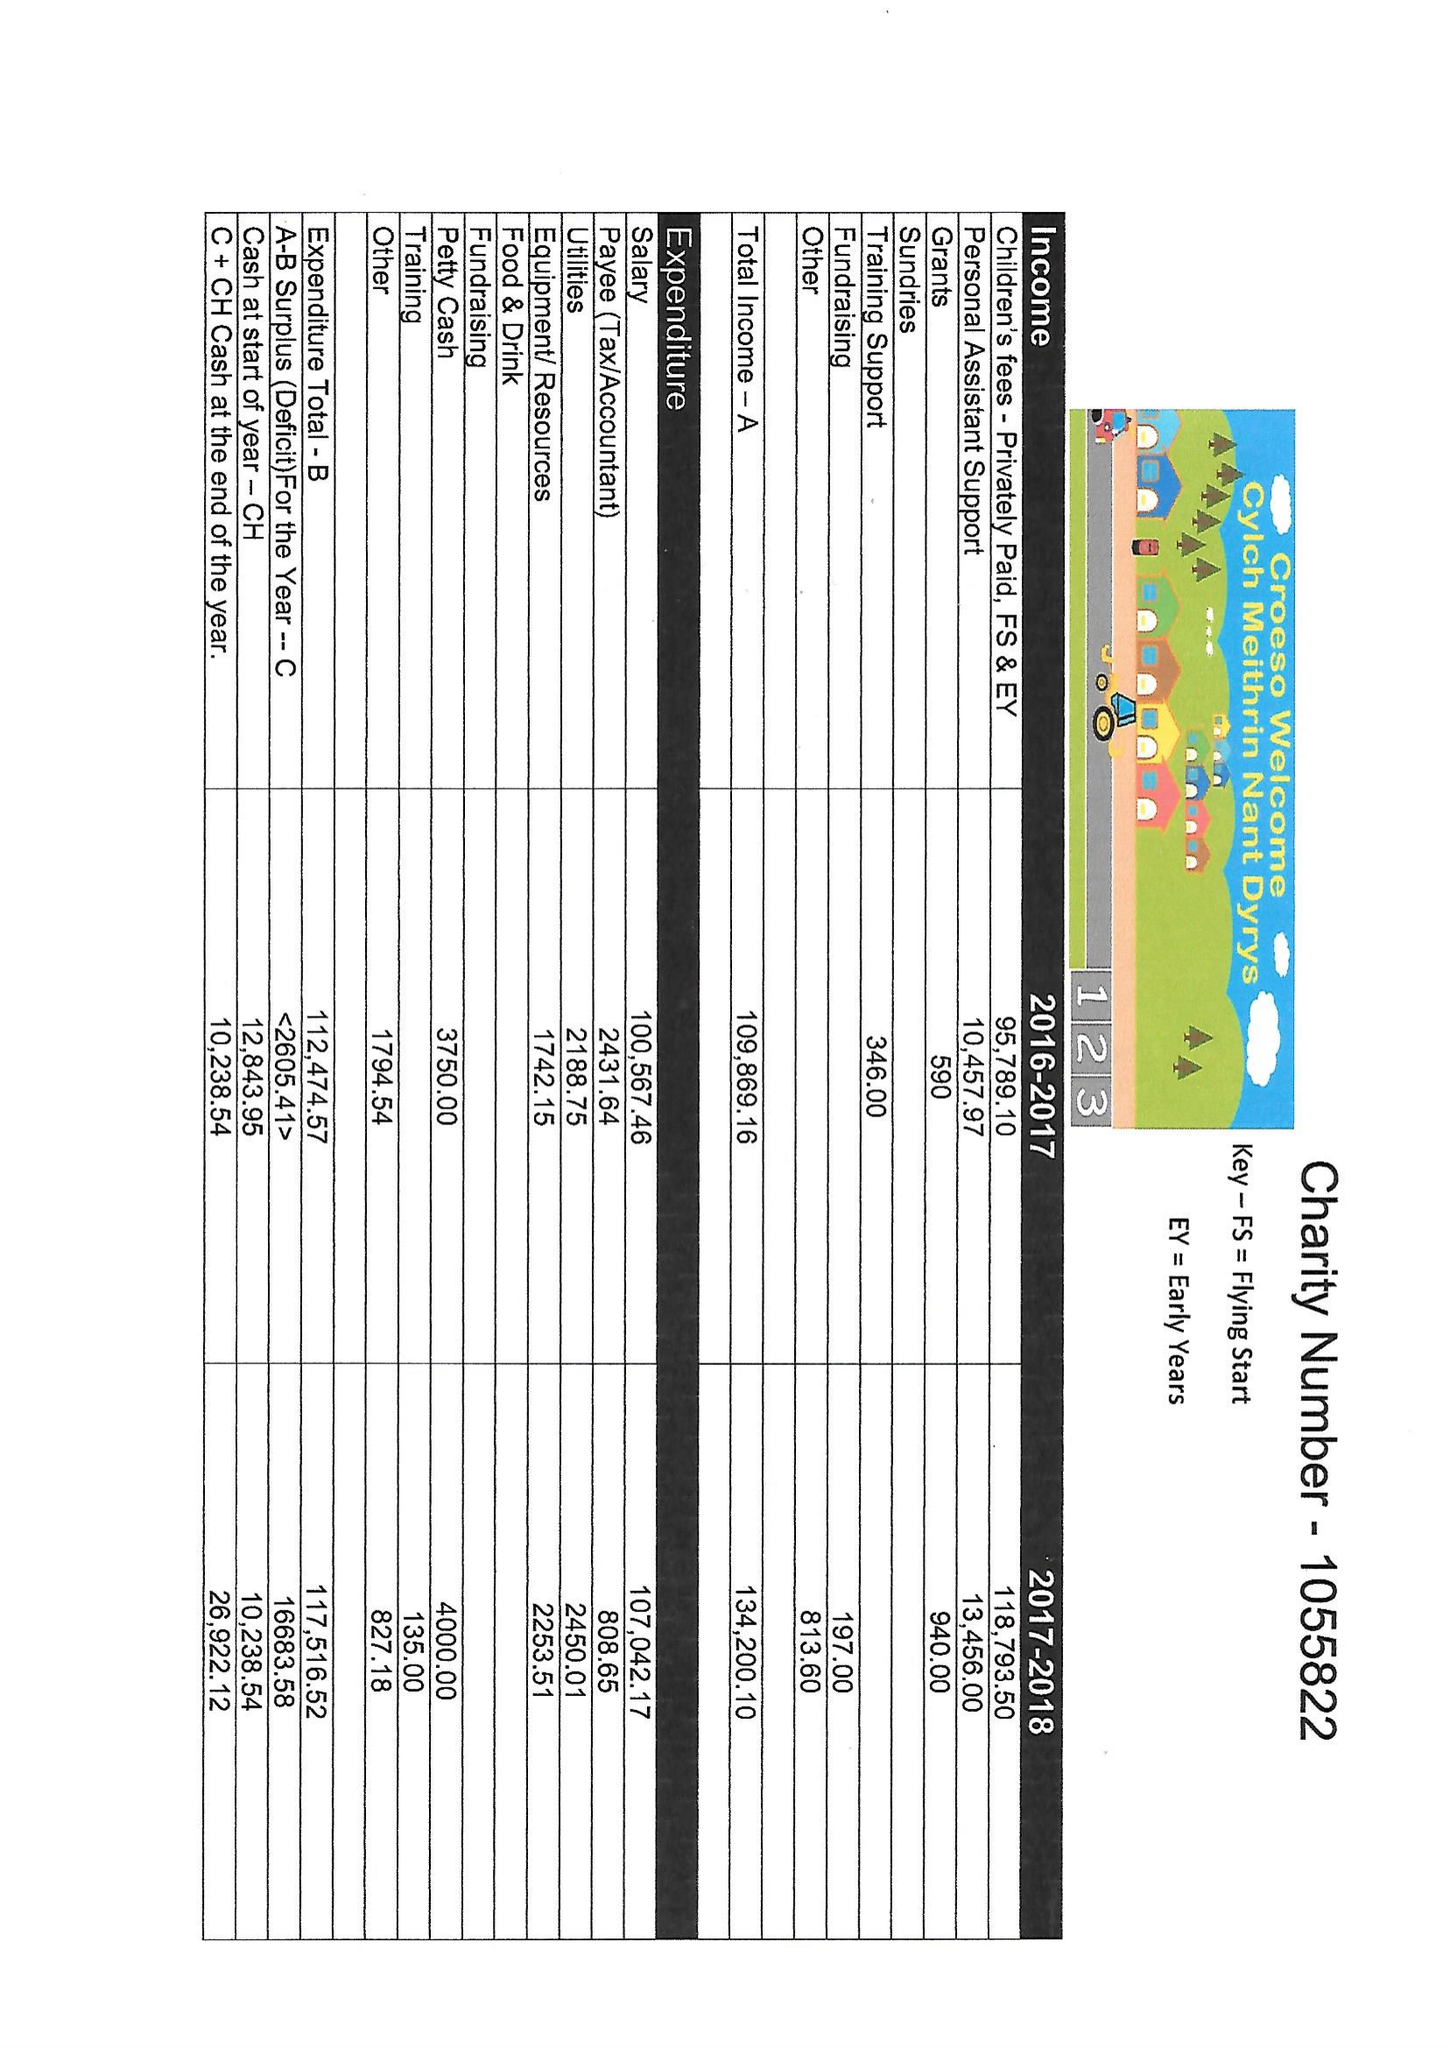What is the value for the address__street_line?
Answer the question using a single word or phrase. CLINIC ROAD 